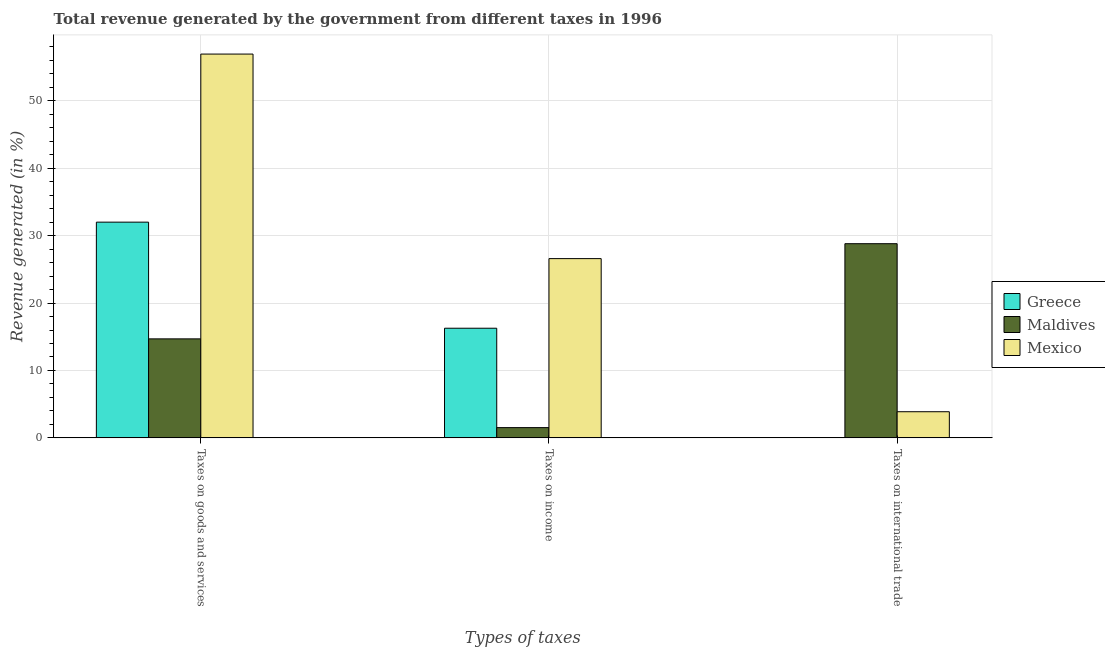How many different coloured bars are there?
Your answer should be compact. 3. Are the number of bars on each tick of the X-axis equal?
Make the answer very short. No. How many bars are there on the 3rd tick from the left?
Offer a very short reply. 2. What is the label of the 2nd group of bars from the left?
Offer a terse response. Taxes on income. What is the percentage of revenue generated by taxes on goods and services in Maldives?
Provide a succinct answer. 14.69. Across all countries, what is the maximum percentage of revenue generated by tax on international trade?
Your answer should be very brief. 28.81. Across all countries, what is the minimum percentage of revenue generated by taxes on goods and services?
Keep it short and to the point. 14.69. What is the total percentage of revenue generated by taxes on goods and services in the graph?
Make the answer very short. 103.63. What is the difference between the percentage of revenue generated by taxes on income in Mexico and that in Greece?
Offer a very short reply. 10.33. What is the difference between the percentage of revenue generated by taxes on goods and services in Greece and the percentage of revenue generated by tax on international trade in Maldives?
Offer a very short reply. 3.2. What is the average percentage of revenue generated by tax on international trade per country?
Your answer should be compact. 10.9. What is the difference between the percentage of revenue generated by taxes on goods and services and percentage of revenue generated by taxes on income in Mexico?
Give a very brief answer. 30.35. In how many countries, is the percentage of revenue generated by taxes on income greater than 14 %?
Give a very brief answer. 2. What is the ratio of the percentage of revenue generated by taxes on income in Maldives to that in Mexico?
Your answer should be compact. 0.06. Is the percentage of revenue generated by taxes on income in Greece less than that in Maldives?
Offer a terse response. No. Is the difference between the percentage of revenue generated by tax on international trade in Maldives and Mexico greater than the difference between the percentage of revenue generated by taxes on income in Maldives and Mexico?
Your answer should be very brief. Yes. What is the difference between the highest and the second highest percentage of revenue generated by taxes on goods and services?
Keep it short and to the point. 24.94. What is the difference between the highest and the lowest percentage of revenue generated by taxes on goods and services?
Provide a short and direct response. 42.25. In how many countries, is the percentage of revenue generated by tax on international trade greater than the average percentage of revenue generated by tax on international trade taken over all countries?
Offer a very short reply. 1. Are all the bars in the graph horizontal?
Provide a short and direct response. No. How many countries are there in the graph?
Offer a terse response. 3. What is the title of the graph?
Your answer should be compact. Total revenue generated by the government from different taxes in 1996. Does "Philippines" appear as one of the legend labels in the graph?
Make the answer very short. No. What is the label or title of the X-axis?
Your answer should be very brief. Types of taxes. What is the label or title of the Y-axis?
Your answer should be very brief. Revenue generated (in %). What is the Revenue generated (in %) in Greece in Taxes on goods and services?
Offer a terse response. 32. What is the Revenue generated (in %) of Maldives in Taxes on goods and services?
Ensure brevity in your answer.  14.69. What is the Revenue generated (in %) in Mexico in Taxes on goods and services?
Make the answer very short. 56.94. What is the Revenue generated (in %) of Greece in Taxes on income?
Your response must be concise. 16.27. What is the Revenue generated (in %) of Maldives in Taxes on income?
Ensure brevity in your answer.  1.52. What is the Revenue generated (in %) in Mexico in Taxes on income?
Keep it short and to the point. 26.59. What is the Revenue generated (in %) in Greece in Taxes on international trade?
Ensure brevity in your answer.  0. What is the Revenue generated (in %) in Maldives in Taxes on international trade?
Make the answer very short. 28.81. What is the Revenue generated (in %) of Mexico in Taxes on international trade?
Ensure brevity in your answer.  3.88. Across all Types of taxes, what is the maximum Revenue generated (in %) of Greece?
Ensure brevity in your answer.  32. Across all Types of taxes, what is the maximum Revenue generated (in %) of Maldives?
Your answer should be compact. 28.81. Across all Types of taxes, what is the maximum Revenue generated (in %) in Mexico?
Offer a terse response. 56.94. Across all Types of taxes, what is the minimum Revenue generated (in %) of Greece?
Give a very brief answer. 0. Across all Types of taxes, what is the minimum Revenue generated (in %) in Maldives?
Provide a short and direct response. 1.52. Across all Types of taxes, what is the minimum Revenue generated (in %) of Mexico?
Make the answer very short. 3.88. What is the total Revenue generated (in %) of Greece in the graph?
Your response must be concise. 48.27. What is the total Revenue generated (in %) of Maldives in the graph?
Give a very brief answer. 45.02. What is the total Revenue generated (in %) in Mexico in the graph?
Keep it short and to the point. 87.41. What is the difference between the Revenue generated (in %) in Greece in Taxes on goods and services and that in Taxes on income?
Make the answer very short. 15.74. What is the difference between the Revenue generated (in %) of Maldives in Taxes on goods and services and that in Taxes on income?
Give a very brief answer. 13.17. What is the difference between the Revenue generated (in %) of Mexico in Taxes on goods and services and that in Taxes on income?
Give a very brief answer. 30.35. What is the difference between the Revenue generated (in %) of Maldives in Taxes on goods and services and that in Taxes on international trade?
Offer a very short reply. -14.12. What is the difference between the Revenue generated (in %) of Mexico in Taxes on goods and services and that in Taxes on international trade?
Offer a very short reply. 53.06. What is the difference between the Revenue generated (in %) in Maldives in Taxes on income and that in Taxes on international trade?
Keep it short and to the point. -27.29. What is the difference between the Revenue generated (in %) of Mexico in Taxes on income and that in Taxes on international trade?
Provide a succinct answer. 22.72. What is the difference between the Revenue generated (in %) of Greece in Taxes on goods and services and the Revenue generated (in %) of Maldives in Taxes on income?
Your answer should be compact. 30.48. What is the difference between the Revenue generated (in %) in Greece in Taxes on goods and services and the Revenue generated (in %) in Mexico in Taxes on income?
Keep it short and to the point. 5.41. What is the difference between the Revenue generated (in %) of Maldives in Taxes on goods and services and the Revenue generated (in %) of Mexico in Taxes on income?
Offer a terse response. -11.91. What is the difference between the Revenue generated (in %) in Greece in Taxes on goods and services and the Revenue generated (in %) in Maldives in Taxes on international trade?
Keep it short and to the point. 3.2. What is the difference between the Revenue generated (in %) of Greece in Taxes on goods and services and the Revenue generated (in %) of Mexico in Taxes on international trade?
Your answer should be very brief. 28.13. What is the difference between the Revenue generated (in %) in Maldives in Taxes on goods and services and the Revenue generated (in %) in Mexico in Taxes on international trade?
Provide a succinct answer. 10.81. What is the difference between the Revenue generated (in %) in Greece in Taxes on income and the Revenue generated (in %) in Maldives in Taxes on international trade?
Offer a terse response. -12.54. What is the difference between the Revenue generated (in %) of Greece in Taxes on income and the Revenue generated (in %) of Mexico in Taxes on international trade?
Your response must be concise. 12.39. What is the difference between the Revenue generated (in %) in Maldives in Taxes on income and the Revenue generated (in %) in Mexico in Taxes on international trade?
Your answer should be compact. -2.36. What is the average Revenue generated (in %) in Greece per Types of taxes?
Ensure brevity in your answer.  16.09. What is the average Revenue generated (in %) in Maldives per Types of taxes?
Make the answer very short. 15.01. What is the average Revenue generated (in %) of Mexico per Types of taxes?
Give a very brief answer. 29.14. What is the difference between the Revenue generated (in %) in Greece and Revenue generated (in %) in Maldives in Taxes on goods and services?
Provide a short and direct response. 17.32. What is the difference between the Revenue generated (in %) in Greece and Revenue generated (in %) in Mexico in Taxes on goods and services?
Offer a terse response. -24.94. What is the difference between the Revenue generated (in %) of Maldives and Revenue generated (in %) of Mexico in Taxes on goods and services?
Provide a succinct answer. -42.25. What is the difference between the Revenue generated (in %) of Greece and Revenue generated (in %) of Maldives in Taxes on income?
Offer a terse response. 14.75. What is the difference between the Revenue generated (in %) in Greece and Revenue generated (in %) in Mexico in Taxes on income?
Offer a very short reply. -10.33. What is the difference between the Revenue generated (in %) in Maldives and Revenue generated (in %) in Mexico in Taxes on income?
Keep it short and to the point. -25.07. What is the difference between the Revenue generated (in %) in Maldives and Revenue generated (in %) in Mexico in Taxes on international trade?
Provide a short and direct response. 24.93. What is the ratio of the Revenue generated (in %) of Greece in Taxes on goods and services to that in Taxes on income?
Give a very brief answer. 1.97. What is the ratio of the Revenue generated (in %) of Maldives in Taxes on goods and services to that in Taxes on income?
Your answer should be very brief. 9.66. What is the ratio of the Revenue generated (in %) in Mexico in Taxes on goods and services to that in Taxes on income?
Provide a short and direct response. 2.14. What is the ratio of the Revenue generated (in %) in Maldives in Taxes on goods and services to that in Taxes on international trade?
Ensure brevity in your answer.  0.51. What is the ratio of the Revenue generated (in %) of Mexico in Taxes on goods and services to that in Taxes on international trade?
Your answer should be very brief. 14.68. What is the ratio of the Revenue generated (in %) of Maldives in Taxes on income to that in Taxes on international trade?
Your response must be concise. 0.05. What is the ratio of the Revenue generated (in %) of Mexico in Taxes on income to that in Taxes on international trade?
Give a very brief answer. 6.86. What is the difference between the highest and the second highest Revenue generated (in %) of Maldives?
Make the answer very short. 14.12. What is the difference between the highest and the second highest Revenue generated (in %) in Mexico?
Give a very brief answer. 30.35. What is the difference between the highest and the lowest Revenue generated (in %) in Greece?
Ensure brevity in your answer.  32. What is the difference between the highest and the lowest Revenue generated (in %) of Maldives?
Keep it short and to the point. 27.29. What is the difference between the highest and the lowest Revenue generated (in %) of Mexico?
Your answer should be very brief. 53.06. 